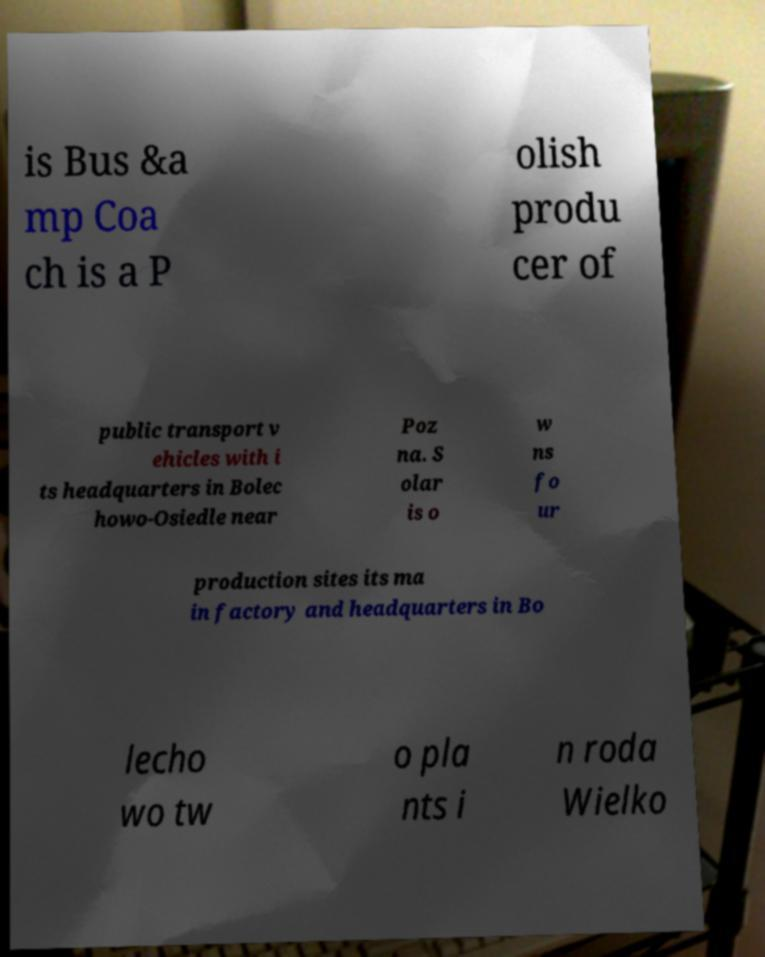Can you accurately transcribe the text from the provided image for me? is Bus &a mp Coa ch is a P olish produ cer of public transport v ehicles with i ts headquarters in Bolec howo-Osiedle near Poz na. S olar is o w ns fo ur production sites its ma in factory and headquarters in Bo lecho wo tw o pla nts i n roda Wielko 